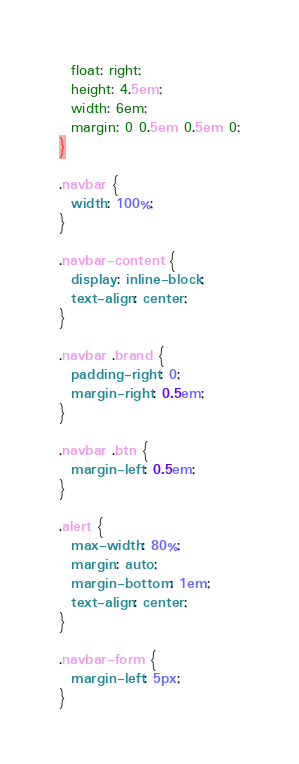Convert code to text. <code><loc_0><loc_0><loc_500><loc_500><_CSS_>  float: right;
  height: 4.5em;
  width: 6em;
  margin: 0 0.5em 0.5em 0;
}

.navbar {
  width: 100%;
}

.navbar-content {
  display: inline-block;
  text-align: center;
}

.navbar .brand {
  padding-right: 0;
  margin-right: 0.5em;
}

.navbar .btn {
  margin-left: 0.5em;
}

.alert {
  max-width: 80%;
  margin: auto;
  margin-bottom: 1em;
  text-align: center;
}

.navbar-form {
  margin-left: 5px;
}
</code> 